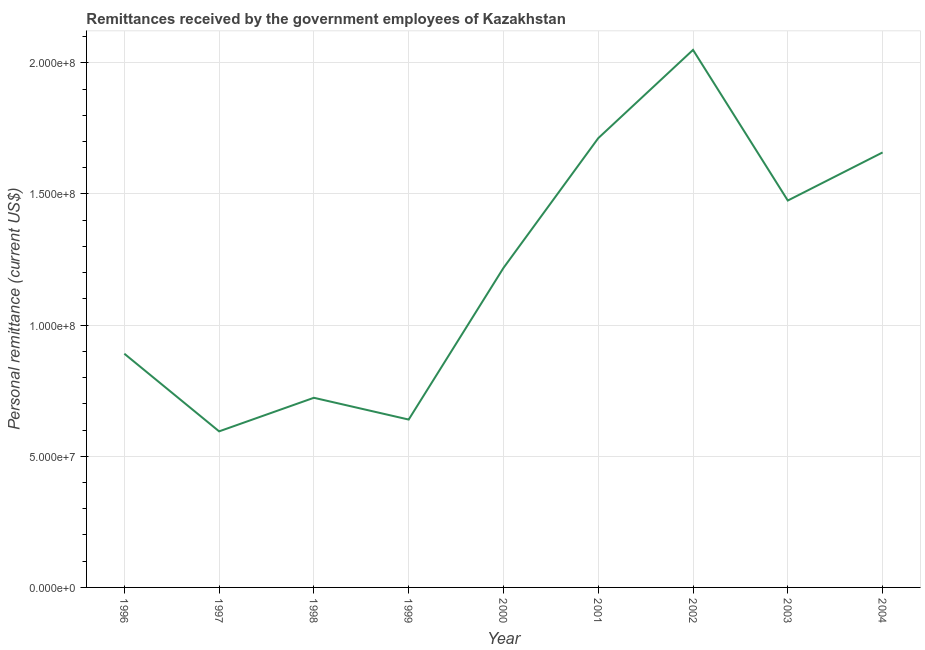What is the personal remittances in 2002?
Your answer should be compact. 2.05e+08. Across all years, what is the maximum personal remittances?
Your response must be concise. 2.05e+08. Across all years, what is the minimum personal remittances?
Offer a very short reply. 5.95e+07. In which year was the personal remittances maximum?
Keep it short and to the point. 2002. In which year was the personal remittances minimum?
Give a very brief answer. 1997. What is the sum of the personal remittances?
Ensure brevity in your answer.  1.10e+09. What is the difference between the personal remittances in 1996 and 2002?
Offer a terse response. -1.16e+08. What is the average personal remittances per year?
Your answer should be compact. 1.22e+08. What is the median personal remittances?
Offer a very short reply. 1.22e+08. In how many years, is the personal remittances greater than 50000000 US$?
Your answer should be very brief. 9. Do a majority of the years between 2001 and 1996 (inclusive) have personal remittances greater than 100000000 US$?
Offer a terse response. Yes. What is the ratio of the personal remittances in 1997 to that in 1999?
Your answer should be compact. 0.93. Is the personal remittances in 2000 less than that in 2003?
Your response must be concise. Yes. Is the difference between the personal remittances in 1999 and 2002 greater than the difference between any two years?
Your response must be concise. No. What is the difference between the highest and the second highest personal remittances?
Offer a terse response. 3.37e+07. Is the sum of the personal remittances in 1996 and 1997 greater than the maximum personal remittances across all years?
Make the answer very short. No. What is the difference between the highest and the lowest personal remittances?
Your response must be concise. 1.45e+08. In how many years, is the personal remittances greater than the average personal remittances taken over all years?
Provide a short and direct response. 4. How many lines are there?
Your response must be concise. 1. How many years are there in the graph?
Your response must be concise. 9. Are the values on the major ticks of Y-axis written in scientific E-notation?
Offer a terse response. Yes. What is the title of the graph?
Make the answer very short. Remittances received by the government employees of Kazakhstan. What is the label or title of the Y-axis?
Make the answer very short. Personal remittance (current US$). What is the Personal remittance (current US$) in 1996?
Make the answer very short. 8.91e+07. What is the Personal remittance (current US$) of 1997?
Your answer should be very brief. 5.95e+07. What is the Personal remittance (current US$) in 1998?
Your answer should be compact. 7.23e+07. What is the Personal remittance (current US$) in 1999?
Give a very brief answer. 6.40e+07. What is the Personal remittance (current US$) in 2000?
Provide a succinct answer. 1.22e+08. What is the Personal remittance (current US$) of 2001?
Offer a terse response. 1.71e+08. What is the Personal remittance (current US$) in 2002?
Keep it short and to the point. 2.05e+08. What is the Personal remittance (current US$) of 2003?
Your answer should be very brief. 1.48e+08. What is the Personal remittance (current US$) of 2004?
Offer a very short reply. 1.66e+08. What is the difference between the Personal remittance (current US$) in 1996 and 1997?
Make the answer very short. 2.96e+07. What is the difference between the Personal remittance (current US$) in 1996 and 1998?
Offer a terse response. 1.68e+07. What is the difference between the Personal remittance (current US$) in 1996 and 1999?
Keep it short and to the point. 2.51e+07. What is the difference between the Personal remittance (current US$) in 1996 and 2000?
Give a very brief answer. -3.27e+07. What is the difference between the Personal remittance (current US$) in 1996 and 2001?
Give a very brief answer. -8.22e+07. What is the difference between the Personal remittance (current US$) in 1996 and 2002?
Ensure brevity in your answer.  -1.16e+08. What is the difference between the Personal remittance (current US$) in 1996 and 2003?
Make the answer very short. -5.84e+07. What is the difference between the Personal remittance (current US$) in 1996 and 2004?
Offer a terse response. -7.67e+07. What is the difference between the Personal remittance (current US$) in 1997 and 1998?
Your response must be concise. -1.28e+07. What is the difference between the Personal remittance (current US$) in 1997 and 1999?
Your answer should be compact. -4.50e+06. What is the difference between the Personal remittance (current US$) in 1997 and 2000?
Your answer should be very brief. -6.23e+07. What is the difference between the Personal remittance (current US$) in 1997 and 2001?
Your answer should be compact. -1.12e+08. What is the difference between the Personal remittance (current US$) in 1997 and 2002?
Your answer should be compact. -1.45e+08. What is the difference between the Personal remittance (current US$) in 1997 and 2003?
Keep it short and to the point. -8.80e+07. What is the difference between the Personal remittance (current US$) in 1997 and 2004?
Provide a succinct answer. -1.06e+08. What is the difference between the Personal remittance (current US$) in 1998 and 1999?
Your answer should be very brief. 8.30e+06. What is the difference between the Personal remittance (current US$) in 1998 and 2000?
Ensure brevity in your answer.  -4.95e+07. What is the difference between the Personal remittance (current US$) in 1998 and 2001?
Your answer should be very brief. -9.90e+07. What is the difference between the Personal remittance (current US$) in 1998 and 2002?
Keep it short and to the point. -1.33e+08. What is the difference between the Personal remittance (current US$) in 1998 and 2003?
Give a very brief answer. -7.52e+07. What is the difference between the Personal remittance (current US$) in 1998 and 2004?
Keep it short and to the point. -9.35e+07. What is the difference between the Personal remittance (current US$) in 1999 and 2000?
Your response must be concise. -5.78e+07. What is the difference between the Personal remittance (current US$) in 1999 and 2001?
Keep it short and to the point. -1.07e+08. What is the difference between the Personal remittance (current US$) in 1999 and 2002?
Offer a terse response. -1.41e+08. What is the difference between the Personal remittance (current US$) in 1999 and 2003?
Offer a very short reply. -8.35e+07. What is the difference between the Personal remittance (current US$) in 1999 and 2004?
Provide a short and direct response. -1.02e+08. What is the difference between the Personal remittance (current US$) in 2000 and 2001?
Offer a very short reply. -4.95e+07. What is the difference between the Personal remittance (current US$) in 2000 and 2002?
Provide a succinct answer. -8.31e+07. What is the difference between the Personal remittance (current US$) in 2000 and 2003?
Your answer should be compact. -2.57e+07. What is the difference between the Personal remittance (current US$) in 2000 and 2004?
Offer a very short reply. -4.40e+07. What is the difference between the Personal remittance (current US$) in 2001 and 2002?
Provide a short and direct response. -3.37e+07. What is the difference between the Personal remittance (current US$) in 2001 and 2003?
Keep it short and to the point. 2.38e+07. What is the difference between the Personal remittance (current US$) in 2001 and 2004?
Keep it short and to the point. 5.44e+06. What is the difference between the Personal remittance (current US$) in 2002 and 2003?
Offer a terse response. 5.74e+07. What is the difference between the Personal remittance (current US$) in 2002 and 2004?
Give a very brief answer. 3.91e+07. What is the difference between the Personal remittance (current US$) in 2003 and 2004?
Offer a terse response. -1.83e+07. What is the ratio of the Personal remittance (current US$) in 1996 to that in 1997?
Your answer should be very brief. 1.5. What is the ratio of the Personal remittance (current US$) in 1996 to that in 1998?
Ensure brevity in your answer.  1.23. What is the ratio of the Personal remittance (current US$) in 1996 to that in 1999?
Make the answer very short. 1.39. What is the ratio of the Personal remittance (current US$) in 1996 to that in 2000?
Keep it short and to the point. 0.73. What is the ratio of the Personal remittance (current US$) in 1996 to that in 2001?
Your response must be concise. 0.52. What is the ratio of the Personal remittance (current US$) in 1996 to that in 2002?
Offer a very short reply. 0.43. What is the ratio of the Personal remittance (current US$) in 1996 to that in 2003?
Make the answer very short. 0.6. What is the ratio of the Personal remittance (current US$) in 1996 to that in 2004?
Ensure brevity in your answer.  0.54. What is the ratio of the Personal remittance (current US$) in 1997 to that in 1998?
Keep it short and to the point. 0.82. What is the ratio of the Personal remittance (current US$) in 1997 to that in 1999?
Make the answer very short. 0.93. What is the ratio of the Personal remittance (current US$) in 1997 to that in 2000?
Give a very brief answer. 0.49. What is the ratio of the Personal remittance (current US$) in 1997 to that in 2001?
Ensure brevity in your answer.  0.35. What is the ratio of the Personal remittance (current US$) in 1997 to that in 2002?
Offer a terse response. 0.29. What is the ratio of the Personal remittance (current US$) in 1997 to that in 2003?
Offer a terse response. 0.4. What is the ratio of the Personal remittance (current US$) in 1997 to that in 2004?
Offer a very short reply. 0.36. What is the ratio of the Personal remittance (current US$) in 1998 to that in 1999?
Give a very brief answer. 1.13. What is the ratio of the Personal remittance (current US$) in 1998 to that in 2000?
Provide a succinct answer. 0.59. What is the ratio of the Personal remittance (current US$) in 1998 to that in 2001?
Give a very brief answer. 0.42. What is the ratio of the Personal remittance (current US$) in 1998 to that in 2002?
Ensure brevity in your answer.  0.35. What is the ratio of the Personal remittance (current US$) in 1998 to that in 2003?
Your response must be concise. 0.49. What is the ratio of the Personal remittance (current US$) in 1998 to that in 2004?
Provide a succinct answer. 0.44. What is the ratio of the Personal remittance (current US$) in 1999 to that in 2000?
Ensure brevity in your answer.  0.53. What is the ratio of the Personal remittance (current US$) in 1999 to that in 2001?
Make the answer very short. 0.37. What is the ratio of the Personal remittance (current US$) in 1999 to that in 2002?
Make the answer very short. 0.31. What is the ratio of the Personal remittance (current US$) in 1999 to that in 2003?
Your answer should be very brief. 0.43. What is the ratio of the Personal remittance (current US$) in 1999 to that in 2004?
Provide a succinct answer. 0.39. What is the ratio of the Personal remittance (current US$) in 2000 to that in 2001?
Provide a succinct answer. 0.71. What is the ratio of the Personal remittance (current US$) in 2000 to that in 2002?
Ensure brevity in your answer.  0.59. What is the ratio of the Personal remittance (current US$) in 2000 to that in 2003?
Provide a short and direct response. 0.83. What is the ratio of the Personal remittance (current US$) in 2000 to that in 2004?
Your answer should be very brief. 0.73. What is the ratio of the Personal remittance (current US$) in 2001 to that in 2002?
Your response must be concise. 0.84. What is the ratio of the Personal remittance (current US$) in 2001 to that in 2003?
Your answer should be compact. 1.16. What is the ratio of the Personal remittance (current US$) in 2001 to that in 2004?
Keep it short and to the point. 1.03. What is the ratio of the Personal remittance (current US$) in 2002 to that in 2003?
Make the answer very short. 1.39. What is the ratio of the Personal remittance (current US$) in 2002 to that in 2004?
Provide a short and direct response. 1.24. What is the ratio of the Personal remittance (current US$) in 2003 to that in 2004?
Offer a terse response. 0.89. 